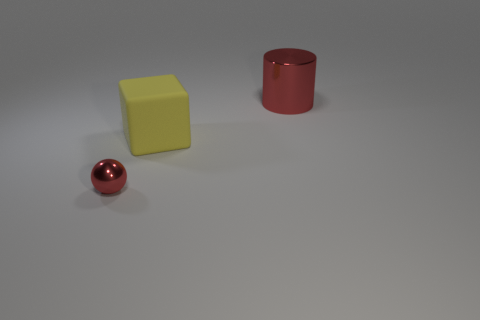Add 2 brown shiny cylinders. How many objects exist? 5 Subtract all cylinders. How many objects are left? 2 Add 3 blocks. How many blocks exist? 4 Subtract 0 blue cylinders. How many objects are left? 3 Subtract all tiny blue rubber blocks. Subtract all balls. How many objects are left? 2 Add 1 red shiny balls. How many red shiny balls are left? 2 